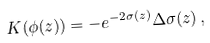<formula> <loc_0><loc_0><loc_500><loc_500>K ( \phi ( z ) ) = - e ^ { - 2 \sigma ( z ) } \Delta \sigma ( z ) \, ,</formula> 